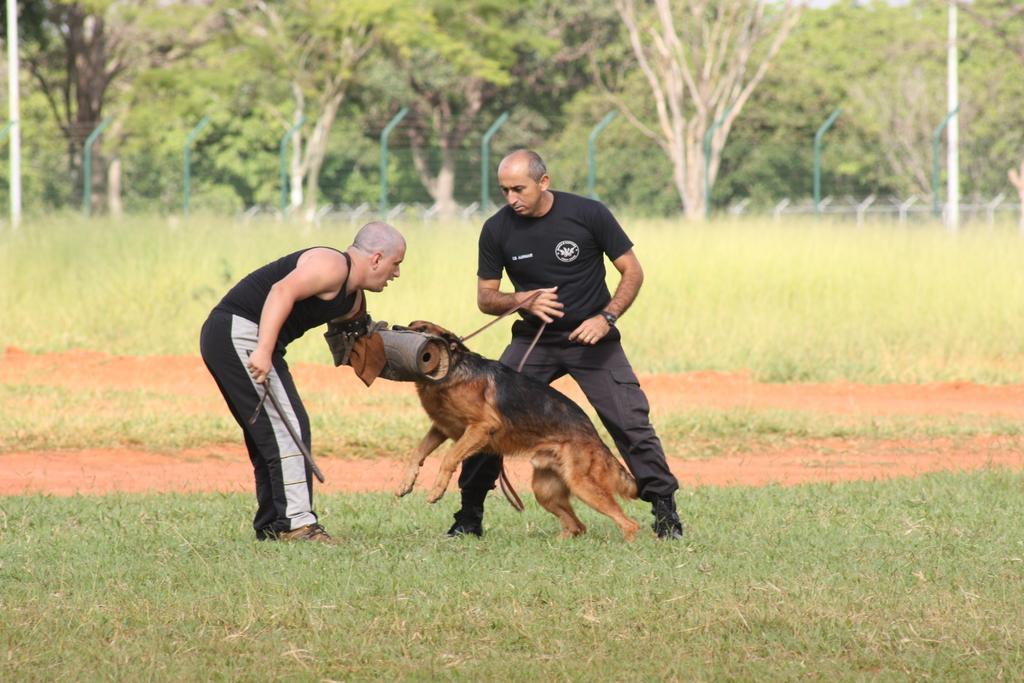Please provide a concise description of this image. picture contains the two persons are playing with the dog and the floor is full of grass and behind the person more trees are there the background is greenery. 